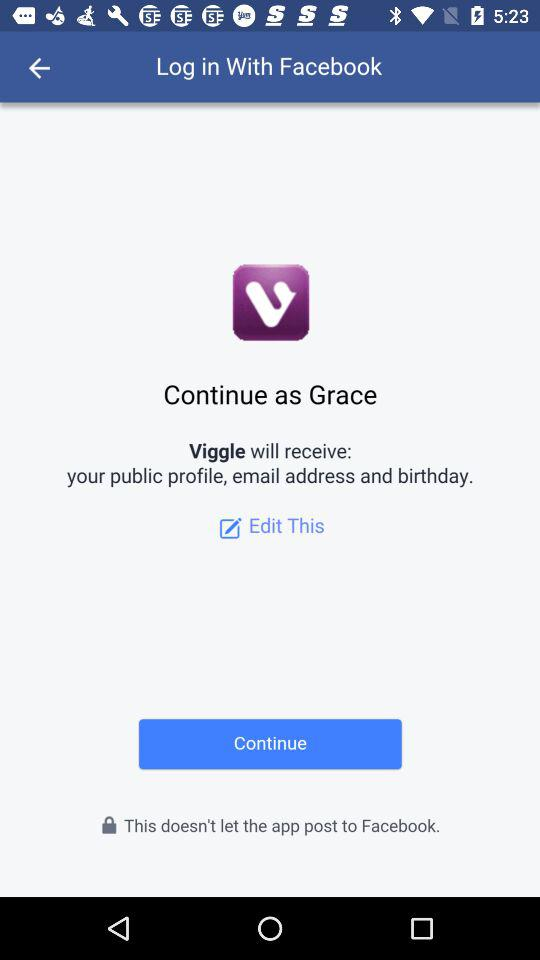What is the user name to continue the profile? The user name is Grace. 